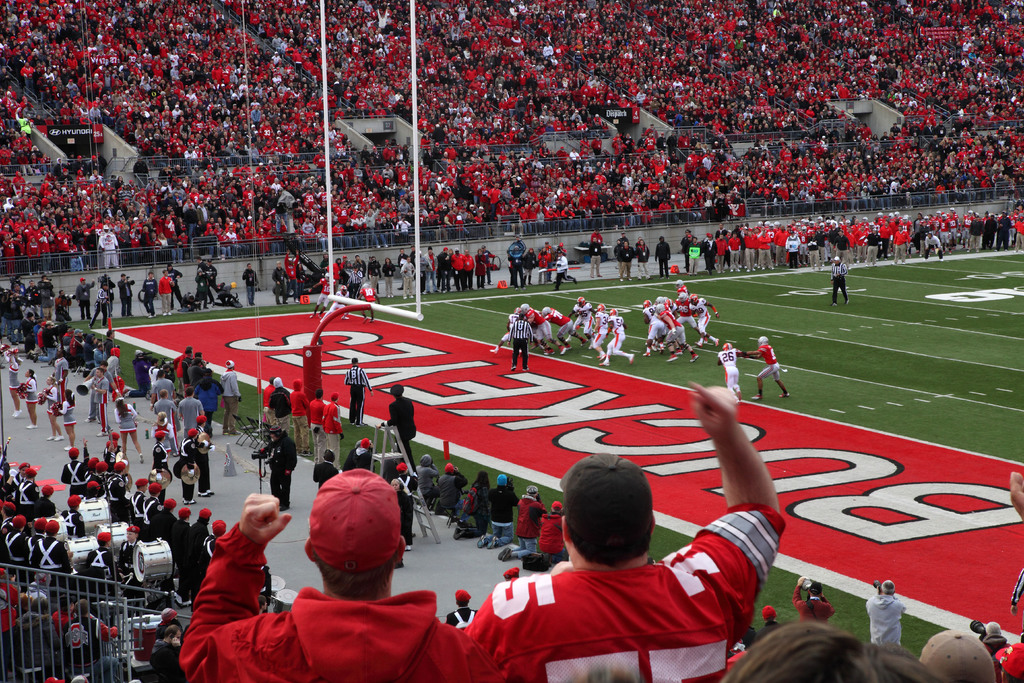Can you describe the main features of this image for me? The image offers a dynamic view of a football game in progress at a large stadium filled with spectators predominantly clad in shades of red, which suggests they are supporters of the home side. Active play is visible on the field, where one team in white uniforms is lined up against another in red. It appears to be a crucial down in the game, given the intense focus of the fans, whose high energy is palpable. Details such as the large scoreboard, end zone designs, and the marching band poised along the sideline add to the authentic and immersive game-day experience represented in the shot. 